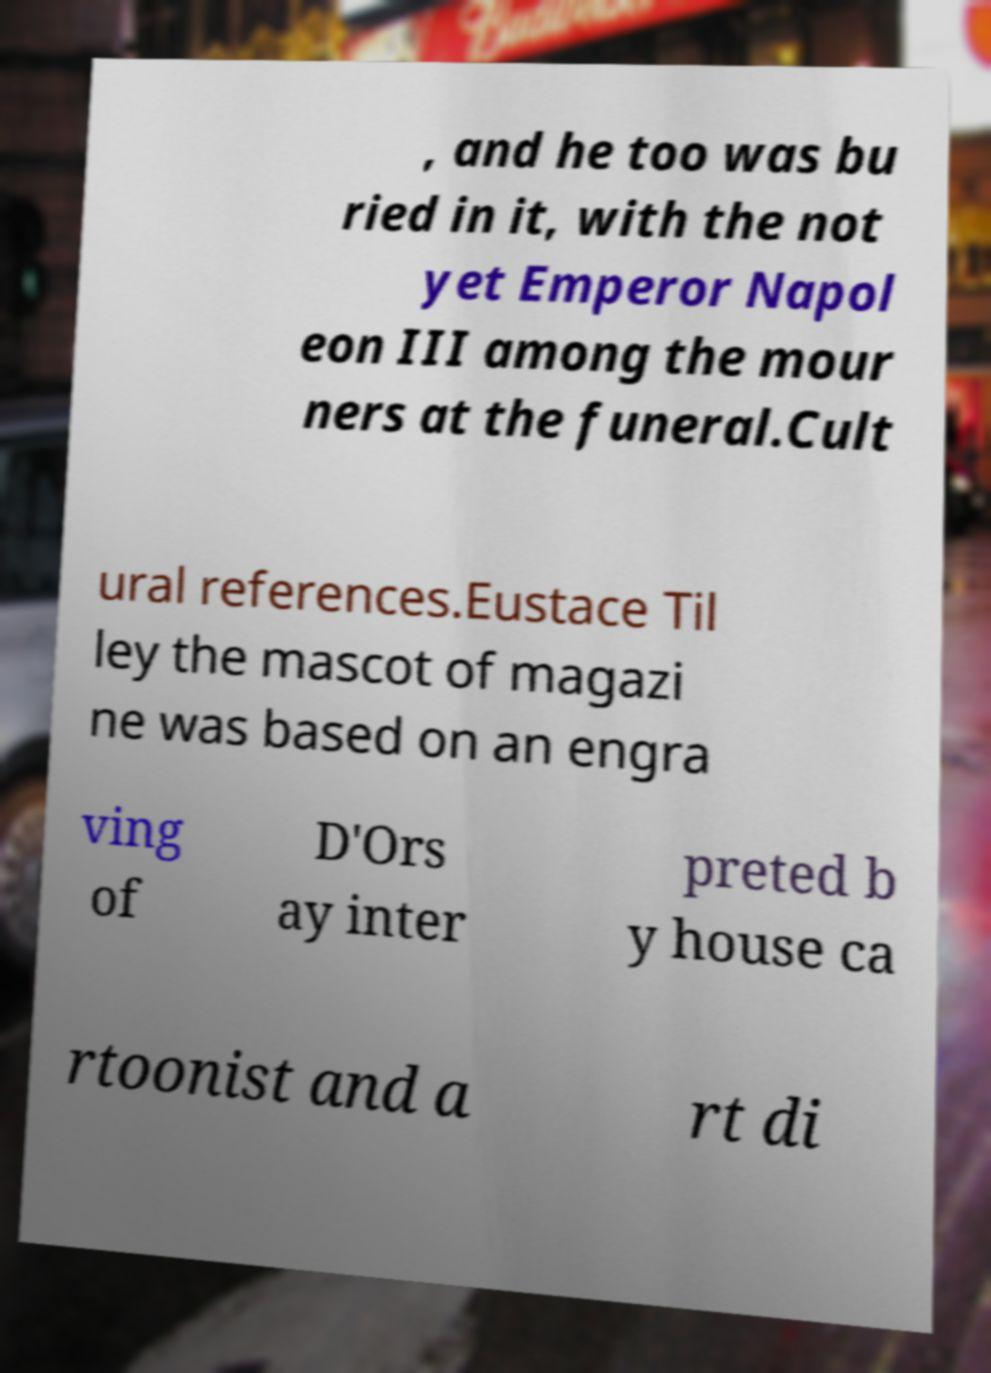Could you extract and type out the text from this image? , and he too was bu ried in it, with the not yet Emperor Napol eon III among the mour ners at the funeral.Cult ural references.Eustace Til ley the mascot of magazi ne was based on an engra ving of D'Ors ay inter preted b y house ca rtoonist and a rt di 